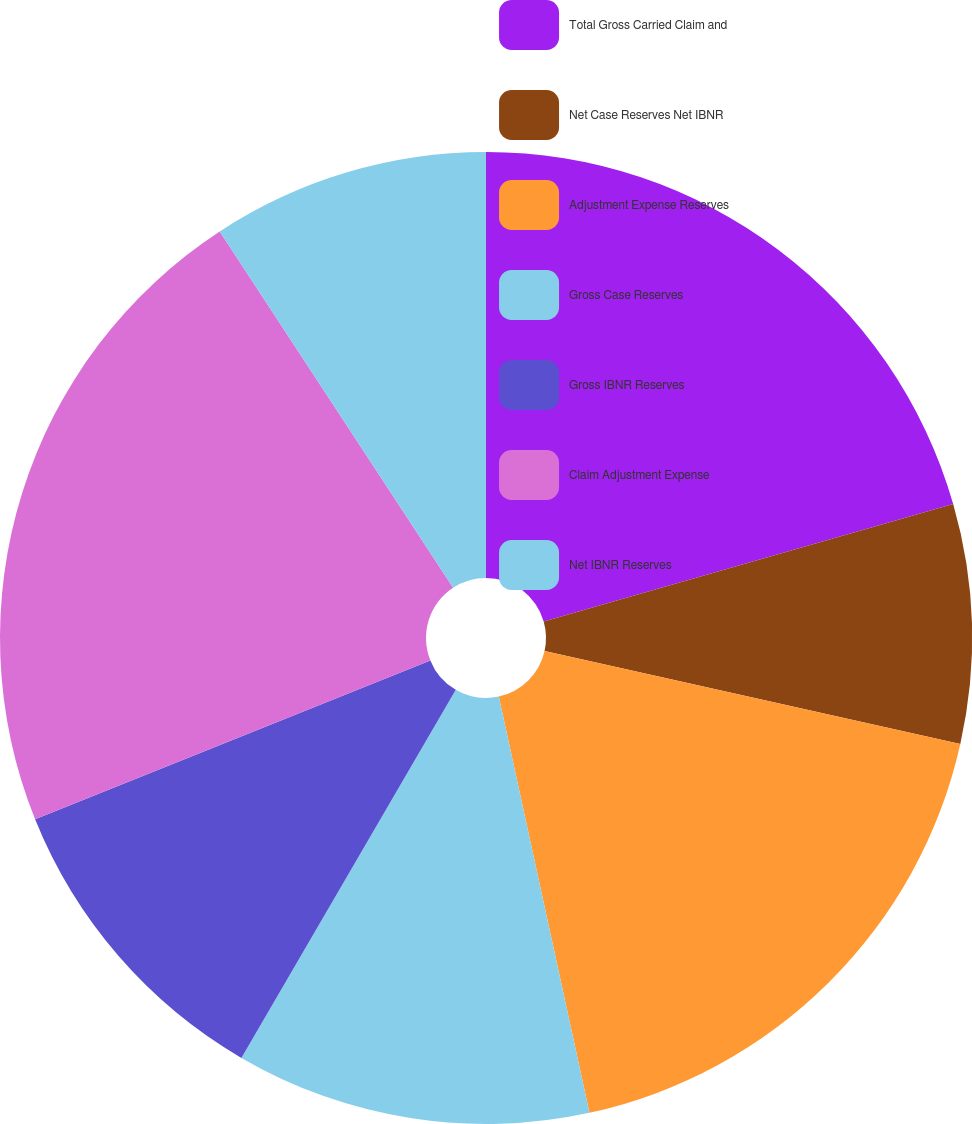Convert chart. <chart><loc_0><loc_0><loc_500><loc_500><pie_chart><fcel>Total Gross Carried Claim and<fcel>Net Case Reserves Net IBNR<fcel>Adjustment Expense Reserves<fcel>Gross Case Reserves<fcel>Gross IBNR Reserves<fcel>Claim Adjustment Expense<fcel>Net IBNR Reserves<nl><fcel>20.56%<fcel>7.94%<fcel>18.09%<fcel>11.81%<fcel>10.52%<fcel>21.86%<fcel>9.23%<nl></chart> 